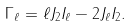<formula> <loc_0><loc_0><loc_500><loc_500>\Gamma _ { \ell } = \ell J _ { 2 } I _ { \ell } - 2 J _ { \ell } I _ { 2 } .</formula> 